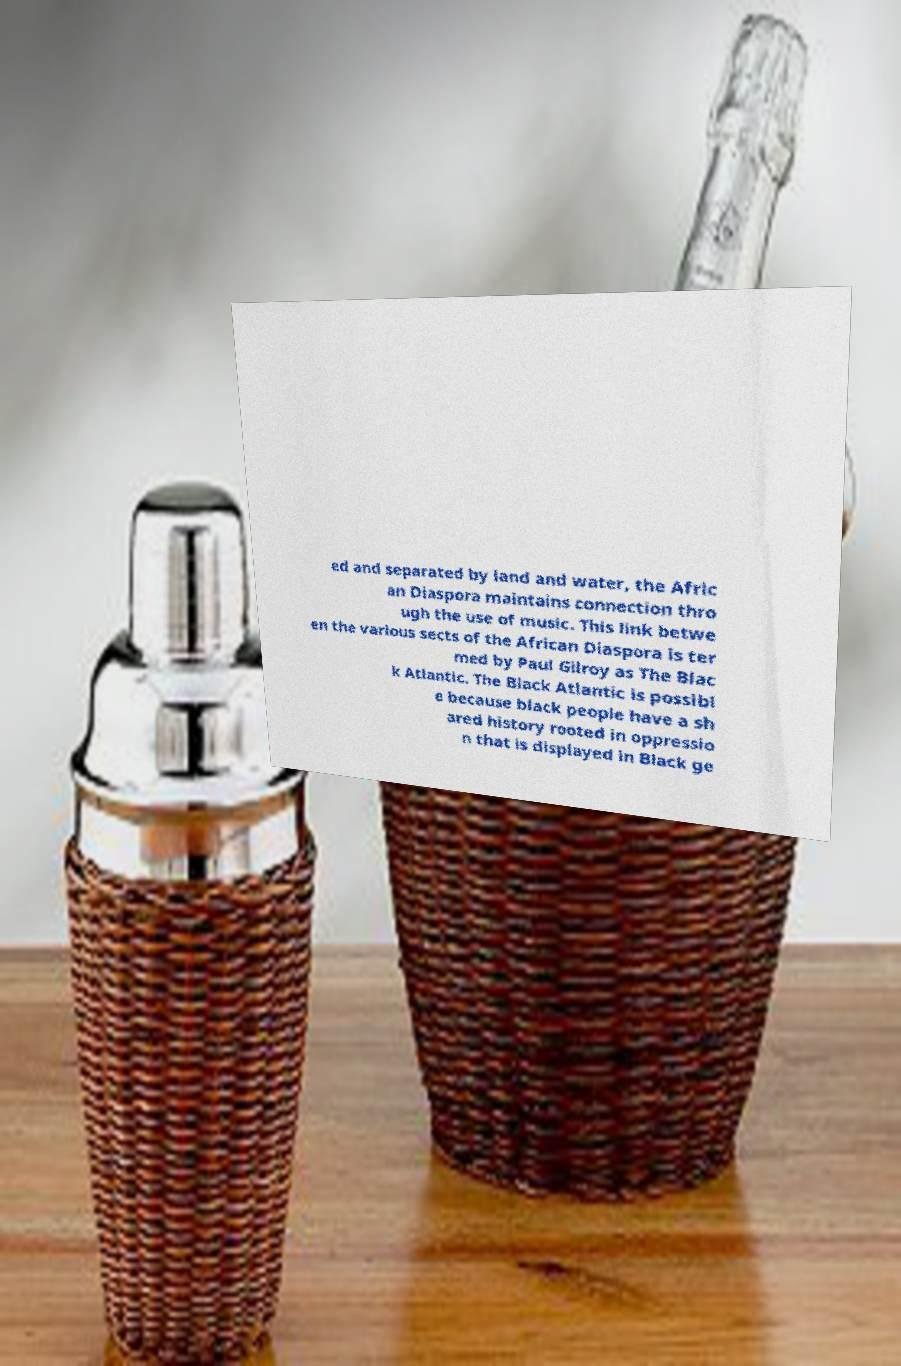Please identify and transcribe the text found in this image. ed and separated by land and water, the Afric an Diaspora maintains connection thro ugh the use of music. This link betwe en the various sects of the African Diaspora is ter med by Paul Gilroy as The Blac k Atlantic. The Black Atlantic is possibl e because black people have a sh ared history rooted in oppressio n that is displayed in Black ge 